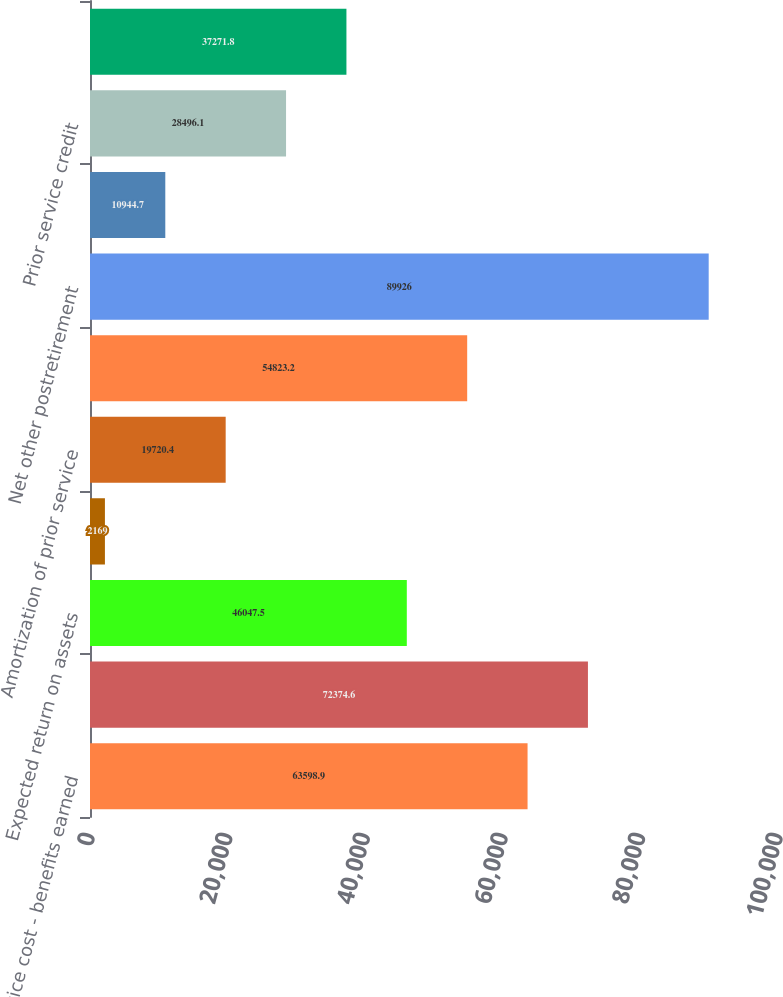<chart> <loc_0><loc_0><loc_500><loc_500><bar_chart><fcel>Service cost - benefits earned<fcel>Interest cost on APBO<fcel>Expected return on assets<fcel>Amortization of transition<fcel>Amortization of prior service<fcel>Recognized net loss<fcel>Net other postretirement<fcel>Transition obligation<fcel>Prior service credit<fcel>Net loss<nl><fcel>63598.9<fcel>72374.6<fcel>46047.5<fcel>2169<fcel>19720.4<fcel>54823.2<fcel>89926<fcel>10944.7<fcel>28496.1<fcel>37271.8<nl></chart> 